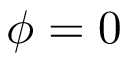Convert formula to latex. <formula><loc_0><loc_0><loc_500><loc_500>\phi = 0</formula> 